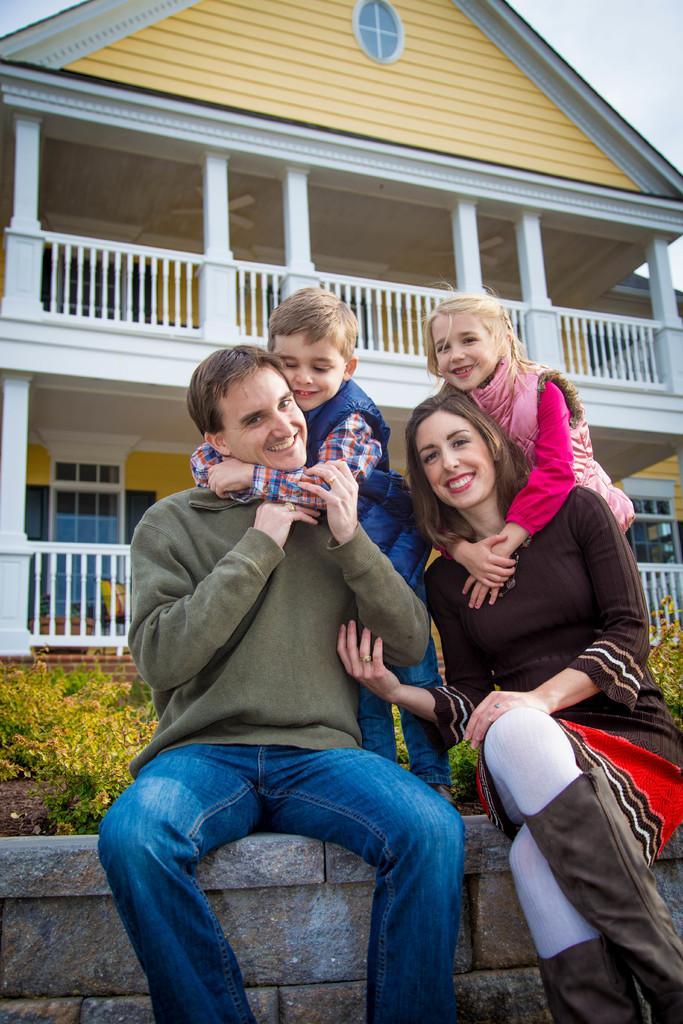Describe this image in one or two sentences. As we can see in the image in the front there are group of people. There is grass, fence, house and there is a sky. 